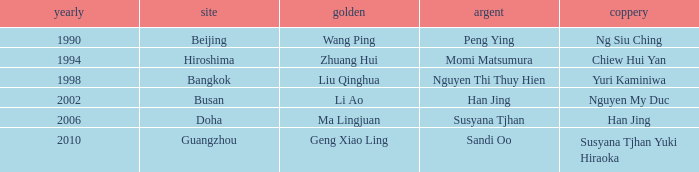What gold is associated with the year 2006? Ma Lingjuan. 